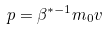<formula> <loc_0><loc_0><loc_500><loc_500>p = \beta ^ { * - 1 } m _ { 0 } v</formula> 